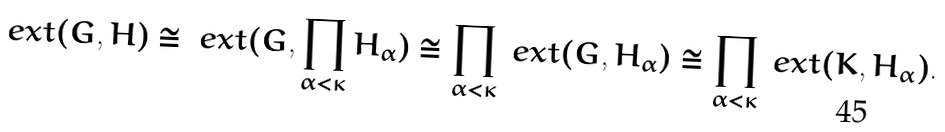<formula> <loc_0><loc_0><loc_500><loc_500>\ e x t ( G , H ) & \cong \ e x t ( G , \prod _ { \alpha < \kappa } H _ { \alpha } ) \cong \prod _ { \alpha < \kappa } \ e x t ( G , H _ { \alpha } ) \cong \prod _ { \alpha < \kappa } \ e x t ( K , H _ { \alpha } ) . \\</formula> 